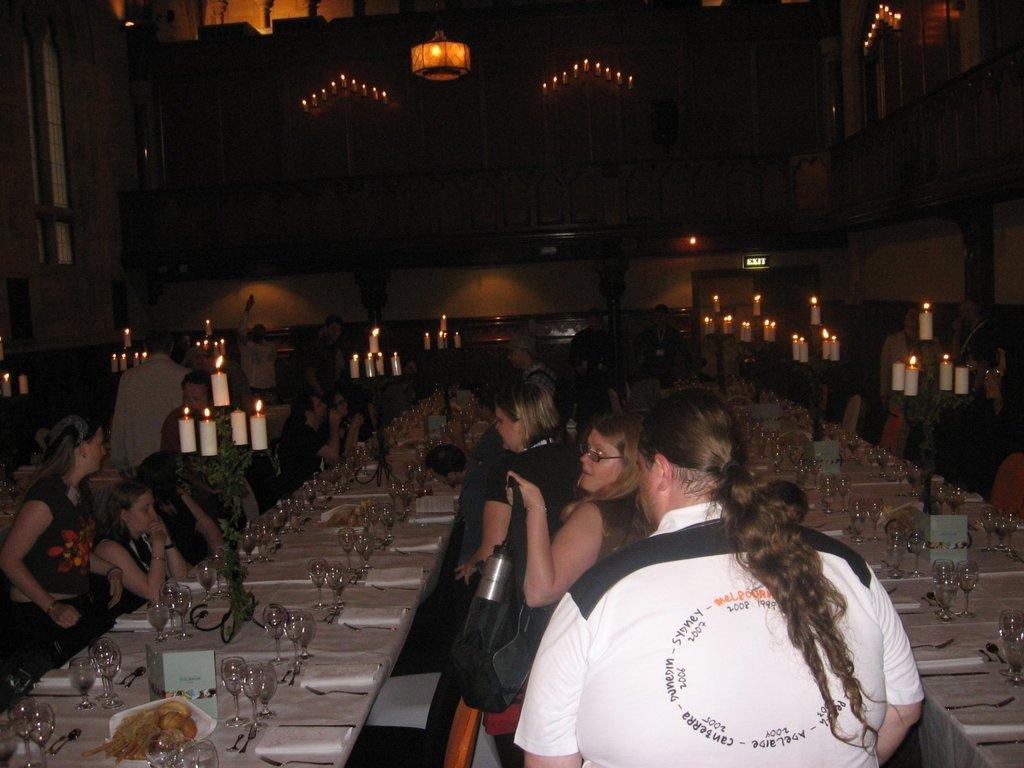Could you give a brief overview of what you see in this image? In this image there are group of persons sitting and standing. There are tables in the center, on the tables there are glasses, spoons, plates, and papers. There are candles on the table. On the top there is a chandelier and in the background there is a wall. 